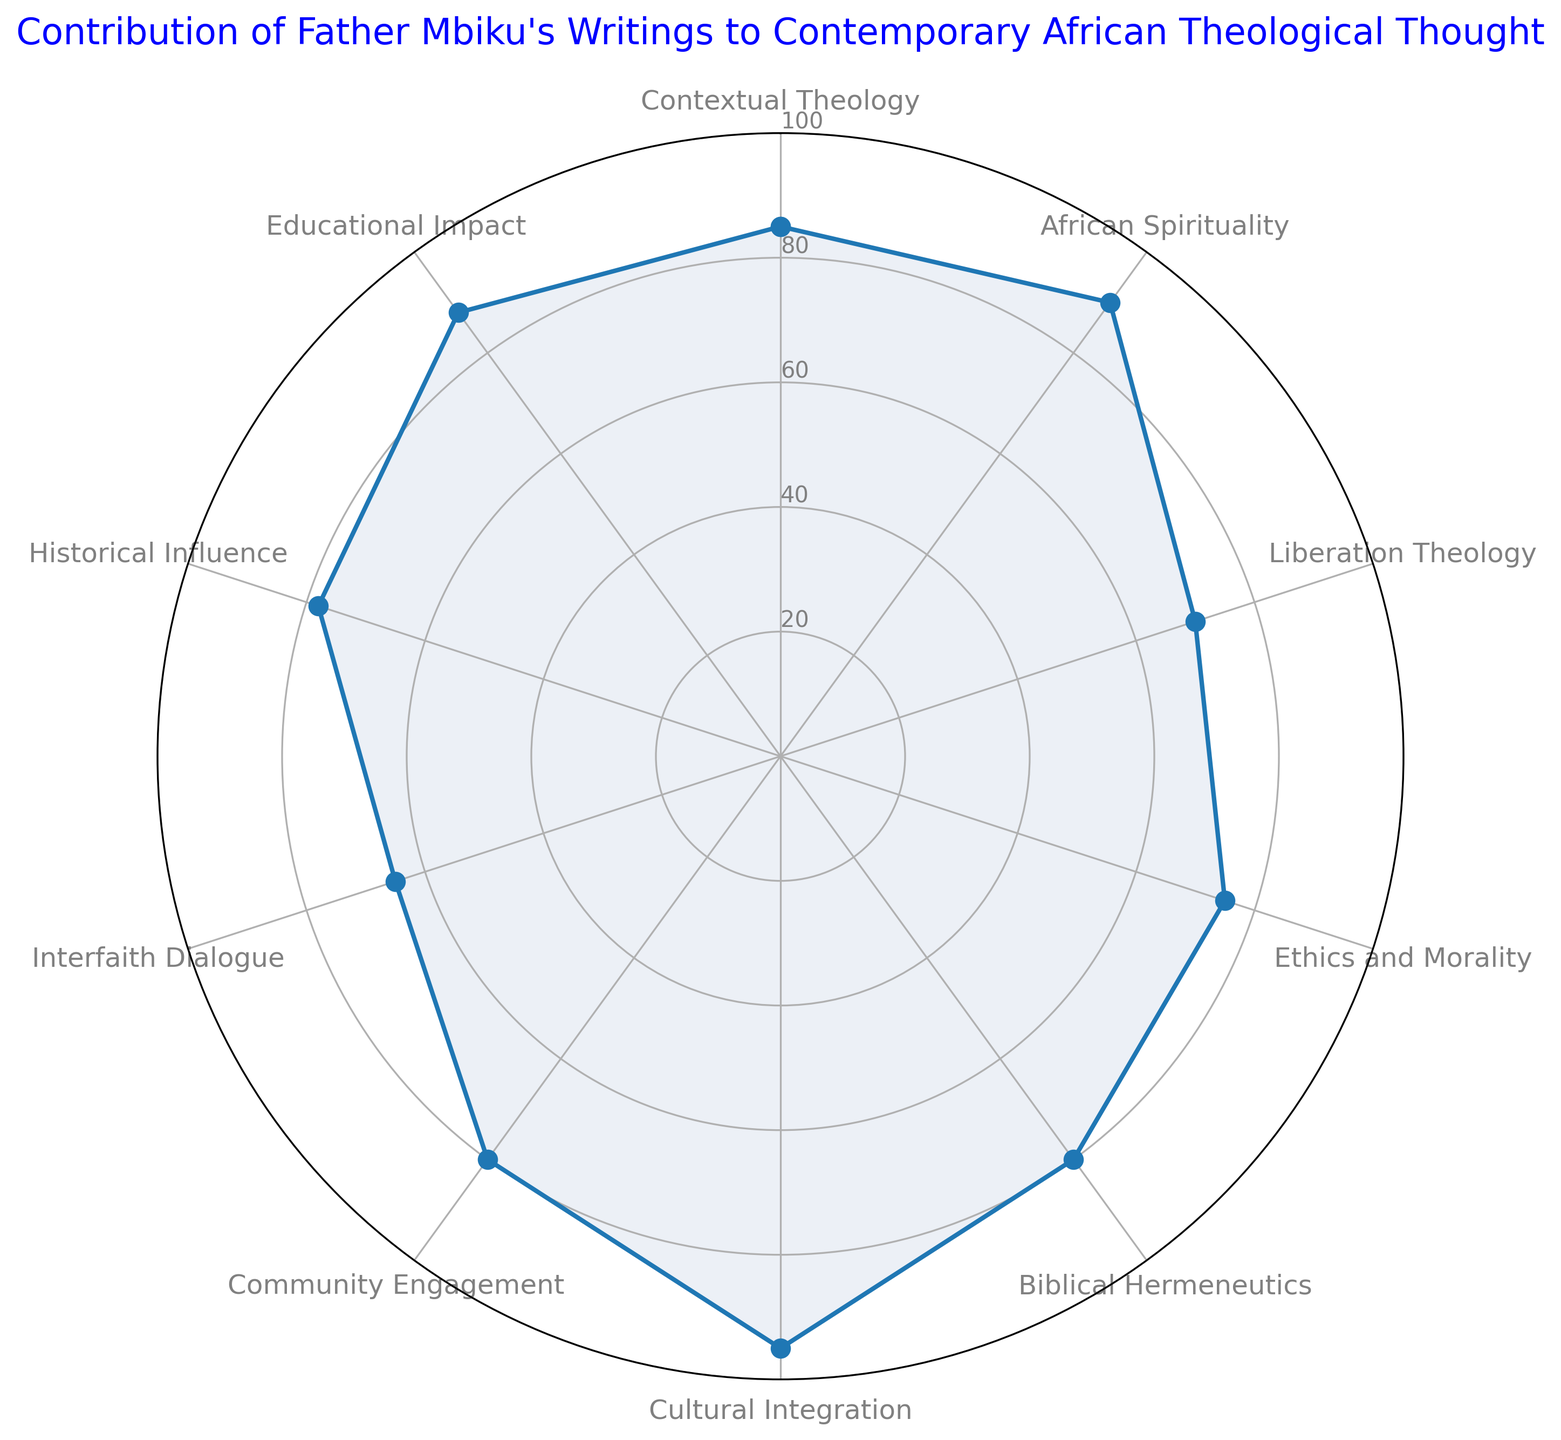What category has the highest value in Father Mbiku's contributions? The radar chart shows that Cultural Integration has the highest value, reaching 95.
Answer: Cultural Integration Which two categories have the lowest contributions, and what are their values? Interfaith Dialogue has the lowest value at 65, followed by Liberation Theology with a value of 70.
Answer: Interfaith Dialogue: 65, Liberation Theology: 70 What is the range of contributions across all categories? The highest value is 95 (Cultural Integration) and the lowest is 65 (Interfaith Dialogue). The range is calculated as 95 - 65.
Answer: 30 Calculate the average contribution of African Spirituality, Historical Influence, and Educational Impact. The values are 90 (African Spirituality), 78 (Historical Influence), and 88 (Educational Impact). The sum is 90 + 78 + 88 = 256. The average is 256 / 3.
Answer: 85.33 How does the contribution of Ethics and Morality compare to Biblical Hermeneutics? Ethics and Morality is 75, while Biblical Hermeneutics is 80. Therefore, Ethics and Morality is 5 units less than Biblical Hermeneutics.
Answer: 5 units less Which categories have contributions greater than 80? The radar chart shows African Spirituality (90), Contextual Theology (85), Cultural Integration (95), and Educational Impact (88) with values greater than 80.
Answer: African Spirituality, Contextual Theology, Cultural Integration, Educational Impact What is the combined contribution of Liberation Theology and Community Engagement? The values are 70 (Liberation Theology) and 80 (Community Engagement). The sum is 70 + 80.
Answer: 150 Identify the category that has the contribution closest to the median value of all categories. To find the median, list all values in order: 65, 70, 75, 78, 80, 80, 85, 88, 90, 95. The median is the average of the 5th and 6th values: (80+80)/2 = 80. Community Engagement and Biblical Hermeneutics both have contributions of 80.
Answer: Community Engagement, Biblical Hermeneutics What is the difference in contribution between Contextual Theology and Historical Influence? Contextual Theology has a value of 85, and Historical Influence has a value of 78. The difference is 85 - 78.
Answer: 7 